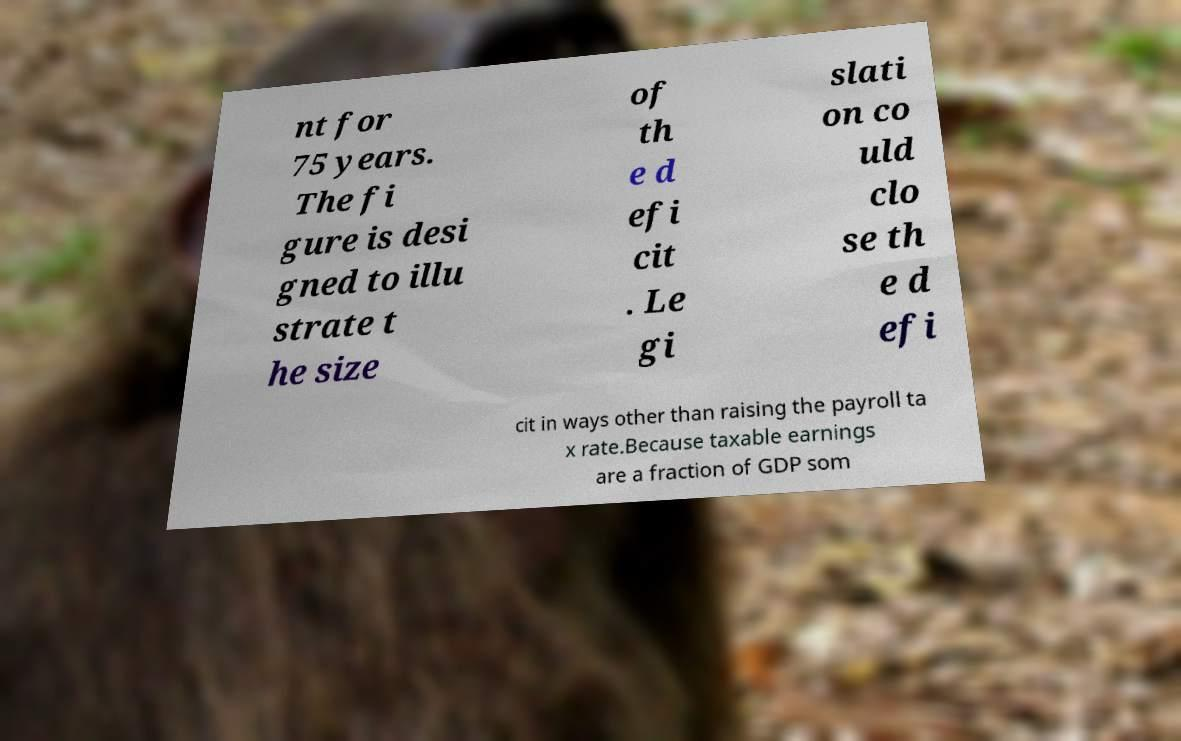For documentation purposes, I need the text within this image transcribed. Could you provide that? nt for 75 years. The fi gure is desi gned to illu strate t he size of th e d efi cit . Le gi slati on co uld clo se th e d efi cit in ways other than raising the payroll ta x rate.Because taxable earnings are a fraction of GDP som 